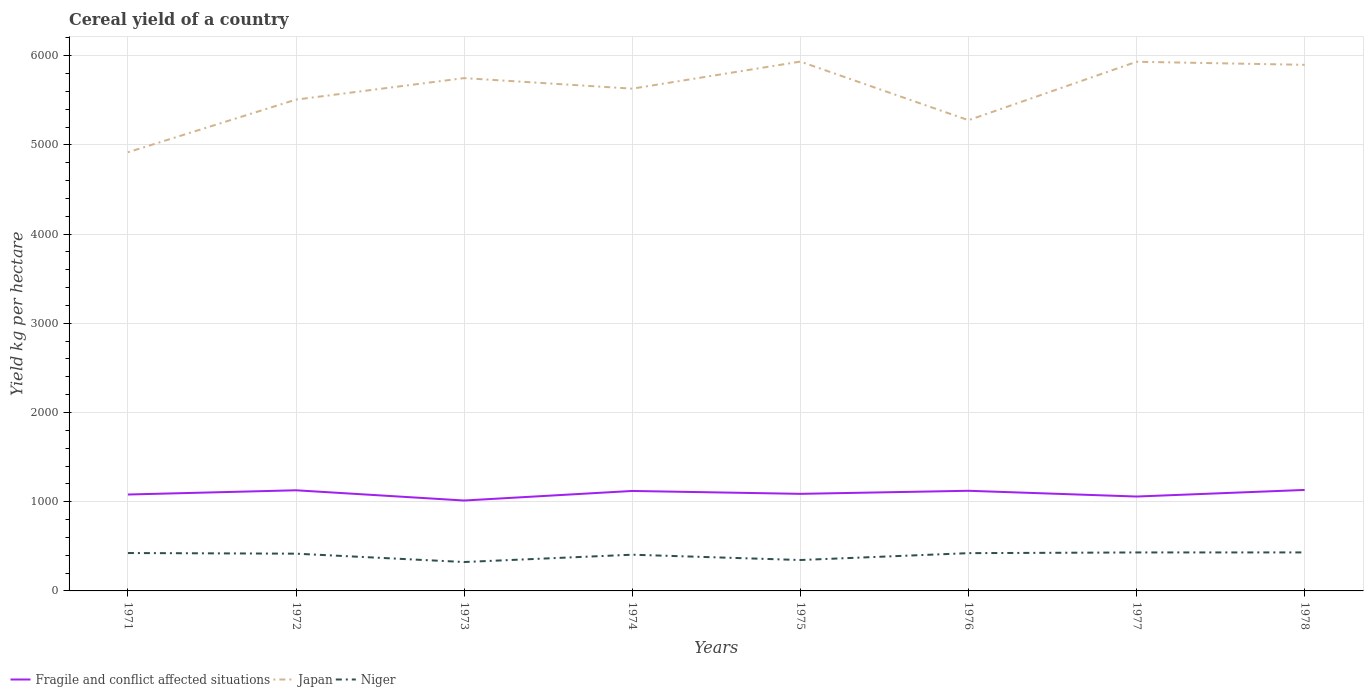Does the line corresponding to Japan intersect with the line corresponding to Fragile and conflict affected situations?
Offer a very short reply. No. Is the number of lines equal to the number of legend labels?
Make the answer very short. Yes. Across all years, what is the maximum total cereal yield in Japan?
Offer a terse response. 4917. What is the total total cereal yield in Fragile and conflict affected situations in the graph?
Your answer should be very brief. 5.6. What is the difference between the highest and the second highest total cereal yield in Niger?
Your answer should be compact. 107.6. What is the difference between the highest and the lowest total cereal yield in Japan?
Your response must be concise. 5. Is the total cereal yield in Niger strictly greater than the total cereal yield in Japan over the years?
Your answer should be very brief. Yes. How many lines are there?
Ensure brevity in your answer.  3. How many years are there in the graph?
Provide a succinct answer. 8. Does the graph contain grids?
Ensure brevity in your answer.  Yes. Where does the legend appear in the graph?
Provide a succinct answer. Bottom left. How many legend labels are there?
Offer a terse response. 3. How are the legend labels stacked?
Provide a succinct answer. Horizontal. What is the title of the graph?
Give a very brief answer. Cereal yield of a country. What is the label or title of the X-axis?
Provide a succinct answer. Years. What is the label or title of the Y-axis?
Your answer should be compact. Yield kg per hectare. What is the Yield kg per hectare of Fragile and conflict affected situations in 1971?
Give a very brief answer. 1080.58. What is the Yield kg per hectare in Japan in 1971?
Make the answer very short. 4917. What is the Yield kg per hectare in Niger in 1971?
Offer a very short reply. 424.77. What is the Yield kg per hectare in Fragile and conflict affected situations in 1972?
Provide a short and direct response. 1128.12. What is the Yield kg per hectare in Japan in 1972?
Offer a very short reply. 5507.19. What is the Yield kg per hectare in Niger in 1972?
Give a very brief answer. 417.58. What is the Yield kg per hectare in Fragile and conflict affected situations in 1973?
Your answer should be compact. 1013.39. What is the Yield kg per hectare in Japan in 1973?
Keep it short and to the point. 5748.08. What is the Yield kg per hectare in Niger in 1973?
Your response must be concise. 323.93. What is the Yield kg per hectare in Fragile and conflict affected situations in 1974?
Provide a short and direct response. 1120.53. What is the Yield kg per hectare in Japan in 1974?
Provide a succinct answer. 5629.96. What is the Yield kg per hectare in Niger in 1974?
Offer a very short reply. 405.96. What is the Yield kg per hectare of Fragile and conflict affected situations in 1975?
Offer a very short reply. 1088.23. What is the Yield kg per hectare of Japan in 1975?
Provide a succinct answer. 5933.27. What is the Yield kg per hectare of Niger in 1975?
Offer a terse response. 346.44. What is the Yield kg per hectare of Fragile and conflict affected situations in 1976?
Make the answer very short. 1122.52. What is the Yield kg per hectare of Japan in 1976?
Give a very brief answer. 5276.19. What is the Yield kg per hectare in Niger in 1976?
Ensure brevity in your answer.  423.41. What is the Yield kg per hectare of Fragile and conflict affected situations in 1977?
Make the answer very short. 1058.09. What is the Yield kg per hectare of Japan in 1977?
Provide a succinct answer. 5931.56. What is the Yield kg per hectare of Niger in 1977?
Your answer should be compact. 431.25. What is the Yield kg per hectare of Fragile and conflict affected situations in 1978?
Provide a succinct answer. 1131.86. What is the Yield kg per hectare of Japan in 1978?
Keep it short and to the point. 5897.02. What is the Yield kg per hectare of Niger in 1978?
Give a very brief answer. 431.54. Across all years, what is the maximum Yield kg per hectare in Fragile and conflict affected situations?
Make the answer very short. 1131.86. Across all years, what is the maximum Yield kg per hectare of Japan?
Your answer should be compact. 5933.27. Across all years, what is the maximum Yield kg per hectare of Niger?
Keep it short and to the point. 431.54. Across all years, what is the minimum Yield kg per hectare in Fragile and conflict affected situations?
Give a very brief answer. 1013.39. Across all years, what is the minimum Yield kg per hectare in Japan?
Provide a succinct answer. 4917. Across all years, what is the minimum Yield kg per hectare of Niger?
Provide a succinct answer. 323.93. What is the total Yield kg per hectare of Fragile and conflict affected situations in the graph?
Your response must be concise. 8743.31. What is the total Yield kg per hectare in Japan in the graph?
Make the answer very short. 4.48e+04. What is the total Yield kg per hectare of Niger in the graph?
Your response must be concise. 3204.89. What is the difference between the Yield kg per hectare in Fragile and conflict affected situations in 1971 and that in 1972?
Provide a succinct answer. -47.54. What is the difference between the Yield kg per hectare in Japan in 1971 and that in 1972?
Keep it short and to the point. -590.19. What is the difference between the Yield kg per hectare of Niger in 1971 and that in 1972?
Give a very brief answer. 7.19. What is the difference between the Yield kg per hectare of Fragile and conflict affected situations in 1971 and that in 1973?
Your answer should be compact. 67.2. What is the difference between the Yield kg per hectare of Japan in 1971 and that in 1973?
Your answer should be very brief. -831.09. What is the difference between the Yield kg per hectare in Niger in 1971 and that in 1973?
Offer a very short reply. 100.84. What is the difference between the Yield kg per hectare of Fragile and conflict affected situations in 1971 and that in 1974?
Offer a terse response. -39.95. What is the difference between the Yield kg per hectare in Japan in 1971 and that in 1974?
Give a very brief answer. -712.96. What is the difference between the Yield kg per hectare of Niger in 1971 and that in 1974?
Give a very brief answer. 18.81. What is the difference between the Yield kg per hectare in Fragile and conflict affected situations in 1971 and that in 1975?
Keep it short and to the point. -7.64. What is the difference between the Yield kg per hectare in Japan in 1971 and that in 1975?
Give a very brief answer. -1016.27. What is the difference between the Yield kg per hectare of Niger in 1971 and that in 1975?
Provide a succinct answer. 78.33. What is the difference between the Yield kg per hectare of Fragile and conflict affected situations in 1971 and that in 1976?
Offer a very short reply. -41.93. What is the difference between the Yield kg per hectare of Japan in 1971 and that in 1976?
Ensure brevity in your answer.  -359.19. What is the difference between the Yield kg per hectare in Niger in 1971 and that in 1976?
Provide a succinct answer. 1.36. What is the difference between the Yield kg per hectare of Fragile and conflict affected situations in 1971 and that in 1977?
Your answer should be very brief. 22.5. What is the difference between the Yield kg per hectare in Japan in 1971 and that in 1977?
Your answer should be compact. -1014.56. What is the difference between the Yield kg per hectare of Niger in 1971 and that in 1977?
Ensure brevity in your answer.  -6.48. What is the difference between the Yield kg per hectare in Fragile and conflict affected situations in 1971 and that in 1978?
Give a very brief answer. -51.28. What is the difference between the Yield kg per hectare of Japan in 1971 and that in 1978?
Make the answer very short. -980.03. What is the difference between the Yield kg per hectare of Niger in 1971 and that in 1978?
Your answer should be very brief. -6.76. What is the difference between the Yield kg per hectare of Fragile and conflict affected situations in 1972 and that in 1973?
Offer a terse response. 114.73. What is the difference between the Yield kg per hectare of Japan in 1972 and that in 1973?
Provide a short and direct response. -240.89. What is the difference between the Yield kg per hectare of Niger in 1972 and that in 1973?
Give a very brief answer. 93.65. What is the difference between the Yield kg per hectare of Fragile and conflict affected situations in 1972 and that in 1974?
Your answer should be very brief. 7.59. What is the difference between the Yield kg per hectare in Japan in 1972 and that in 1974?
Offer a terse response. -122.77. What is the difference between the Yield kg per hectare of Niger in 1972 and that in 1974?
Provide a short and direct response. 11.62. What is the difference between the Yield kg per hectare in Fragile and conflict affected situations in 1972 and that in 1975?
Offer a very short reply. 39.89. What is the difference between the Yield kg per hectare in Japan in 1972 and that in 1975?
Your response must be concise. -426.08. What is the difference between the Yield kg per hectare in Niger in 1972 and that in 1975?
Your answer should be very brief. 71.14. What is the difference between the Yield kg per hectare of Fragile and conflict affected situations in 1972 and that in 1976?
Keep it short and to the point. 5.6. What is the difference between the Yield kg per hectare of Japan in 1972 and that in 1976?
Provide a short and direct response. 231. What is the difference between the Yield kg per hectare in Niger in 1972 and that in 1976?
Ensure brevity in your answer.  -5.83. What is the difference between the Yield kg per hectare of Fragile and conflict affected situations in 1972 and that in 1977?
Give a very brief answer. 70.03. What is the difference between the Yield kg per hectare in Japan in 1972 and that in 1977?
Your response must be concise. -424.37. What is the difference between the Yield kg per hectare of Niger in 1972 and that in 1977?
Give a very brief answer. -13.67. What is the difference between the Yield kg per hectare of Fragile and conflict affected situations in 1972 and that in 1978?
Ensure brevity in your answer.  -3.74. What is the difference between the Yield kg per hectare in Japan in 1972 and that in 1978?
Make the answer very short. -389.83. What is the difference between the Yield kg per hectare in Niger in 1972 and that in 1978?
Offer a very short reply. -13.95. What is the difference between the Yield kg per hectare in Fragile and conflict affected situations in 1973 and that in 1974?
Keep it short and to the point. -107.15. What is the difference between the Yield kg per hectare in Japan in 1973 and that in 1974?
Give a very brief answer. 118.12. What is the difference between the Yield kg per hectare in Niger in 1973 and that in 1974?
Make the answer very short. -82.03. What is the difference between the Yield kg per hectare in Fragile and conflict affected situations in 1973 and that in 1975?
Offer a very short reply. -74.84. What is the difference between the Yield kg per hectare in Japan in 1973 and that in 1975?
Make the answer very short. -185.19. What is the difference between the Yield kg per hectare in Niger in 1973 and that in 1975?
Keep it short and to the point. -22.51. What is the difference between the Yield kg per hectare in Fragile and conflict affected situations in 1973 and that in 1976?
Your answer should be compact. -109.13. What is the difference between the Yield kg per hectare in Japan in 1973 and that in 1976?
Provide a short and direct response. 471.89. What is the difference between the Yield kg per hectare of Niger in 1973 and that in 1976?
Your answer should be very brief. -99.47. What is the difference between the Yield kg per hectare in Fragile and conflict affected situations in 1973 and that in 1977?
Your answer should be compact. -44.7. What is the difference between the Yield kg per hectare in Japan in 1973 and that in 1977?
Provide a succinct answer. -183.48. What is the difference between the Yield kg per hectare of Niger in 1973 and that in 1977?
Keep it short and to the point. -107.32. What is the difference between the Yield kg per hectare of Fragile and conflict affected situations in 1973 and that in 1978?
Offer a terse response. -118.47. What is the difference between the Yield kg per hectare of Japan in 1973 and that in 1978?
Provide a short and direct response. -148.94. What is the difference between the Yield kg per hectare in Niger in 1973 and that in 1978?
Offer a terse response. -107.6. What is the difference between the Yield kg per hectare of Fragile and conflict affected situations in 1974 and that in 1975?
Keep it short and to the point. 32.31. What is the difference between the Yield kg per hectare of Japan in 1974 and that in 1975?
Offer a terse response. -303.31. What is the difference between the Yield kg per hectare of Niger in 1974 and that in 1975?
Your answer should be compact. 59.52. What is the difference between the Yield kg per hectare in Fragile and conflict affected situations in 1974 and that in 1976?
Give a very brief answer. -1.98. What is the difference between the Yield kg per hectare in Japan in 1974 and that in 1976?
Your answer should be compact. 353.77. What is the difference between the Yield kg per hectare of Niger in 1974 and that in 1976?
Your answer should be very brief. -17.45. What is the difference between the Yield kg per hectare of Fragile and conflict affected situations in 1974 and that in 1977?
Offer a terse response. 62.45. What is the difference between the Yield kg per hectare of Japan in 1974 and that in 1977?
Provide a succinct answer. -301.6. What is the difference between the Yield kg per hectare of Niger in 1974 and that in 1977?
Keep it short and to the point. -25.29. What is the difference between the Yield kg per hectare of Fragile and conflict affected situations in 1974 and that in 1978?
Provide a succinct answer. -11.33. What is the difference between the Yield kg per hectare of Japan in 1974 and that in 1978?
Your answer should be very brief. -267.07. What is the difference between the Yield kg per hectare of Niger in 1974 and that in 1978?
Offer a terse response. -25.57. What is the difference between the Yield kg per hectare of Fragile and conflict affected situations in 1975 and that in 1976?
Provide a short and direct response. -34.29. What is the difference between the Yield kg per hectare in Japan in 1975 and that in 1976?
Provide a short and direct response. 657.08. What is the difference between the Yield kg per hectare in Niger in 1975 and that in 1976?
Your answer should be compact. -76.97. What is the difference between the Yield kg per hectare of Fragile and conflict affected situations in 1975 and that in 1977?
Make the answer very short. 30.14. What is the difference between the Yield kg per hectare of Japan in 1975 and that in 1977?
Make the answer very short. 1.71. What is the difference between the Yield kg per hectare of Niger in 1975 and that in 1977?
Your answer should be very brief. -84.81. What is the difference between the Yield kg per hectare in Fragile and conflict affected situations in 1975 and that in 1978?
Your answer should be very brief. -43.64. What is the difference between the Yield kg per hectare in Japan in 1975 and that in 1978?
Your answer should be very brief. 36.24. What is the difference between the Yield kg per hectare in Niger in 1975 and that in 1978?
Offer a terse response. -85.09. What is the difference between the Yield kg per hectare of Fragile and conflict affected situations in 1976 and that in 1977?
Your answer should be very brief. 64.43. What is the difference between the Yield kg per hectare in Japan in 1976 and that in 1977?
Offer a terse response. -655.37. What is the difference between the Yield kg per hectare in Niger in 1976 and that in 1977?
Your response must be concise. -7.84. What is the difference between the Yield kg per hectare of Fragile and conflict affected situations in 1976 and that in 1978?
Keep it short and to the point. -9.35. What is the difference between the Yield kg per hectare of Japan in 1976 and that in 1978?
Your response must be concise. -620.84. What is the difference between the Yield kg per hectare of Niger in 1976 and that in 1978?
Ensure brevity in your answer.  -8.13. What is the difference between the Yield kg per hectare in Fragile and conflict affected situations in 1977 and that in 1978?
Provide a succinct answer. -73.77. What is the difference between the Yield kg per hectare in Japan in 1977 and that in 1978?
Offer a very short reply. 34.53. What is the difference between the Yield kg per hectare in Niger in 1977 and that in 1978?
Make the answer very short. -0.28. What is the difference between the Yield kg per hectare of Fragile and conflict affected situations in 1971 and the Yield kg per hectare of Japan in 1972?
Your response must be concise. -4426.61. What is the difference between the Yield kg per hectare of Fragile and conflict affected situations in 1971 and the Yield kg per hectare of Niger in 1972?
Provide a succinct answer. 663. What is the difference between the Yield kg per hectare in Japan in 1971 and the Yield kg per hectare in Niger in 1972?
Provide a succinct answer. 4499.41. What is the difference between the Yield kg per hectare in Fragile and conflict affected situations in 1971 and the Yield kg per hectare in Japan in 1973?
Provide a succinct answer. -4667.5. What is the difference between the Yield kg per hectare of Fragile and conflict affected situations in 1971 and the Yield kg per hectare of Niger in 1973?
Provide a short and direct response. 756.65. What is the difference between the Yield kg per hectare of Japan in 1971 and the Yield kg per hectare of Niger in 1973?
Provide a succinct answer. 4593.06. What is the difference between the Yield kg per hectare of Fragile and conflict affected situations in 1971 and the Yield kg per hectare of Japan in 1974?
Ensure brevity in your answer.  -4549.37. What is the difference between the Yield kg per hectare in Fragile and conflict affected situations in 1971 and the Yield kg per hectare in Niger in 1974?
Your answer should be very brief. 674.62. What is the difference between the Yield kg per hectare in Japan in 1971 and the Yield kg per hectare in Niger in 1974?
Your response must be concise. 4511.03. What is the difference between the Yield kg per hectare of Fragile and conflict affected situations in 1971 and the Yield kg per hectare of Japan in 1975?
Keep it short and to the point. -4852.68. What is the difference between the Yield kg per hectare in Fragile and conflict affected situations in 1971 and the Yield kg per hectare in Niger in 1975?
Offer a terse response. 734.14. What is the difference between the Yield kg per hectare in Japan in 1971 and the Yield kg per hectare in Niger in 1975?
Make the answer very short. 4570.55. What is the difference between the Yield kg per hectare of Fragile and conflict affected situations in 1971 and the Yield kg per hectare of Japan in 1976?
Your answer should be compact. -4195.6. What is the difference between the Yield kg per hectare of Fragile and conflict affected situations in 1971 and the Yield kg per hectare of Niger in 1976?
Provide a succinct answer. 657.17. What is the difference between the Yield kg per hectare of Japan in 1971 and the Yield kg per hectare of Niger in 1976?
Keep it short and to the point. 4493.59. What is the difference between the Yield kg per hectare in Fragile and conflict affected situations in 1971 and the Yield kg per hectare in Japan in 1977?
Your response must be concise. -4850.97. What is the difference between the Yield kg per hectare of Fragile and conflict affected situations in 1971 and the Yield kg per hectare of Niger in 1977?
Offer a terse response. 649.33. What is the difference between the Yield kg per hectare in Japan in 1971 and the Yield kg per hectare in Niger in 1977?
Provide a succinct answer. 4485.74. What is the difference between the Yield kg per hectare in Fragile and conflict affected situations in 1971 and the Yield kg per hectare in Japan in 1978?
Keep it short and to the point. -4816.44. What is the difference between the Yield kg per hectare of Fragile and conflict affected situations in 1971 and the Yield kg per hectare of Niger in 1978?
Provide a succinct answer. 649.05. What is the difference between the Yield kg per hectare of Japan in 1971 and the Yield kg per hectare of Niger in 1978?
Provide a short and direct response. 4485.46. What is the difference between the Yield kg per hectare in Fragile and conflict affected situations in 1972 and the Yield kg per hectare in Japan in 1973?
Offer a very short reply. -4619.96. What is the difference between the Yield kg per hectare in Fragile and conflict affected situations in 1972 and the Yield kg per hectare in Niger in 1973?
Provide a short and direct response. 804.18. What is the difference between the Yield kg per hectare of Japan in 1972 and the Yield kg per hectare of Niger in 1973?
Your response must be concise. 5183.26. What is the difference between the Yield kg per hectare in Fragile and conflict affected situations in 1972 and the Yield kg per hectare in Japan in 1974?
Your answer should be compact. -4501.84. What is the difference between the Yield kg per hectare in Fragile and conflict affected situations in 1972 and the Yield kg per hectare in Niger in 1974?
Your answer should be compact. 722.16. What is the difference between the Yield kg per hectare in Japan in 1972 and the Yield kg per hectare in Niger in 1974?
Ensure brevity in your answer.  5101.23. What is the difference between the Yield kg per hectare of Fragile and conflict affected situations in 1972 and the Yield kg per hectare of Japan in 1975?
Your response must be concise. -4805.15. What is the difference between the Yield kg per hectare in Fragile and conflict affected situations in 1972 and the Yield kg per hectare in Niger in 1975?
Provide a short and direct response. 781.68. What is the difference between the Yield kg per hectare in Japan in 1972 and the Yield kg per hectare in Niger in 1975?
Offer a very short reply. 5160.75. What is the difference between the Yield kg per hectare of Fragile and conflict affected situations in 1972 and the Yield kg per hectare of Japan in 1976?
Offer a terse response. -4148.07. What is the difference between the Yield kg per hectare in Fragile and conflict affected situations in 1972 and the Yield kg per hectare in Niger in 1976?
Give a very brief answer. 704.71. What is the difference between the Yield kg per hectare in Japan in 1972 and the Yield kg per hectare in Niger in 1976?
Your answer should be compact. 5083.78. What is the difference between the Yield kg per hectare of Fragile and conflict affected situations in 1972 and the Yield kg per hectare of Japan in 1977?
Your answer should be very brief. -4803.44. What is the difference between the Yield kg per hectare in Fragile and conflict affected situations in 1972 and the Yield kg per hectare in Niger in 1977?
Provide a short and direct response. 696.87. What is the difference between the Yield kg per hectare in Japan in 1972 and the Yield kg per hectare in Niger in 1977?
Your response must be concise. 5075.94. What is the difference between the Yield kg per hectare of Fragile and conflict affected situations in 1972 and the Yield kg per hectare of Japan in 1978?
Your answer should be very brief. -4768.9. What is the difference between the Yield kg per hectare in Fragile and conflict affected situations in 1972 and the Yield kg per hectare in Niger in 1978?
Keep it short and to the point. 696.58. What is the difference between the Yield kg per hectare in Japan in 1972 and the Yield kg per hectare in Niger in 1978?
Your answer should be compact. 5075.65. What is the difference between the Yield kg per hectare of Fragile and conflict affected situations in 1973 and the Yield kg per hectare of Japan in 1974?
Your response must be concise. -4616.57. What is the difference between the Yield kg per hectare in Fragile and conflict affected situations in 1973 and the Yield kg per hectare in Niger in 1974?
Make the answer very short. 607.43. What is the difference between the Yield kg per hectare in Japan in 1973 and the Yield kg per hectare in Niger in 1974?
Your answer should be compact. 5342.12. What is the difference between the Yield kg per hectare in Fragile and conflict affected situations in 1973 and the Yield kg per hectare in Japan in 1975?
Provide a succinct answer. -4919.88. What is the difference between the Yield kg per hectare in Fragile and conflict affected situations in 1973 and the Yield kg per hectare in Niger in 1975?
Your answer should be very brief. 666.95. What is the difference between the Yield kg per hectare of Japan in 1973 and the Yield kg per hectare of Niger in 1975?
Make the answer very short. 5401.64. What is the difference between the Yield kg per hectare of Fragile and conflict affected situations in 1973 and the Yield kg per hectare of Japan in 1976?
Keep it short and to the point. -4262.8. What is the difference between the Yield kg per hectare in Fragile and conflict affected situations in 1973 and the Yield kg per hectare in Niger in 1976?
Your answer should be compact. 589.98. What is the difference between the Yield kg per hectare in Japan in 1973 and the Yield kg per hectare in Niger in 1976?
Provide a short and direct response. 5324.67. What is the difference between the Yield kg per hectare in Fragile and conflict affected situations in 1973 and the Yield kg per hectare in Japan in 1977?
Provide a succinct answer. -4918.17. What is the difference between the Yield kg per hectare in Fragile and conflict affected situations in 1973 and the Yield kg per hectare in Niger in 1977?
Make the answer very short. 582.13. What is the difference between the Yield kg per hectare of Japan in 1973 and the Yield kg per hectare of Niger in 1977?
Offer a terse response. 5316.83. What is the difference between the Yield kg per hectare in Fragile and conflict affected situations in 1973 and the Yield kg per hectare in Japan in 1978?
Offer a very short reply. -4883.64. What is the difference between the Yield kg per hectare of Fragile and conflict affected situations in 1973 and the Yield kg per hectare of Niger in 1978?
Offer a very short reply. 581.85. What is the difference between the Yield kg per hectare in Japan in 1973 and the Yield kg per hectare in Niger in 1978?
Give a very brief answer. 5316.55. What is the difference between the Yield kg per hectare of Fragile and conflict affected situations in 1974 and the Yield kg per hectare of Japan in 1975?
Give a very brief answer. -4812.73. What is the difference between the Yield kg per hectare in Fragile and conflict affected situations in 1974 and the Yield kg per hectare in Niger in 1975?
Give a very brief answer. 774.09. What is the difference between the Yield kg per hectare in Japan in 1974 and the Yield kg per hectare in Niger in 1975?
Keep it short and to the point. 5283.51. What is the difference between the Yield kg per hectare of Fragile and conflict affected situations in 1974 and the Yield kg per hectare of Japan in 1976?
Your response must be concise. -4155.65. What is the difference between the Yield kg per hectare of Fragile and conflict affected situations in 1974 and the Yield kg per hectare of Niger in 1976?
Give a very brief answer. 697.12. What is the difference between the Yield kg per hectare in Japan in 1974 and the Yield kg per hectare in Niger in 1976?
Give a very brief answer. 5206.55. What is the difference between the Yield kg per hectare of Fragile and conflict affected situations in 1974 and the Yield kg per hectare of Japan in 1977?
Provide a succinct answer. -4811.02. What is the difference between the Yield kg per hectare of Fragile and conflict affected situations in 1974 and the Yield kg per hectare of Niger in 1977?
Ensure brevity in your answer.  689.28. What is the difference between the Yield kg per hectare in Japan in 1974 and the Yield kg per hectare in Niger in 1977?
Your answer should be very brief. 5198.7. What is the difference between the Yield kg per hectare in Fragile and conflict affected situations in 1974 and the Yield kg per hectare in Japan in 1978?
Offer a very short reply. -4776.49. What is the difference between the Yield kg per hectare in Fragile and conflict affected situations in 1974 and the Yield kg per hectare in Niger in 1978?
Provide a short and direct response. 689. What is the difference between the Yield kg per hectare of Japan in 1974 and the Yield kg per hectare of Niger in 1978?
Your response must be concise. 5198.42. What is the difference between the Yield kg per hectare of Fragile and conflict affected situations in 1975 and the Yield kg per hectare of Japan in 1976?
Offer a very short reply. -4187.96. What is the difference between the Yield kg per hectare of Fragile and conflict affected situations in 1975 and the Yield kg per hectare of Niger in 1976?
Ensure brevity in your answer.  664.82. What is the difference between the Yield kg per hectare of Japan in 1975 and the Yield kg per hectare of Niger in 1976?
Keep it short and to the point. 5509.86. What is the difference between the Yield kg per hectare in Fragile and conflict affected situations in 1975 and the Yield kg per hectare in Japan in 1977?
Make the answer very short. -4843.33. What is the difference between the Yield kg per hectare of Fragile and conflict affected situations in 1975 and the Yield kg per hectare of Niger in 1977?
Your answer should be compact. 656.97. What is the difference between the Yield kg per hectare of Japan in 1975 and the Yield kg per hectare of Niger in 1977?
Make the answer very short. 5502.01. What is the difference between the Yield kg per hectare in Fragile and conflict affected situations in 1975 and the Yield kg per hectare in Japan in 1978?
Provide a short and direct response. -4808.8. What is the difference between the Yield kg per hectare of Fragile and conflict affected situations in 1975 and the Yield kg per hectare of Niger in 1978?
Provide a short and direct response. 656.69. What is the difference between the Yield kg per hectare in Japan in 1975 and the Yield kg per hectare in Niger in 1978?
Provide a short and direct response. 5501.73. What is the difference between the Yield kg per hectare of Fragile and conflict affected situations in 1976 and the Yield kg per hectare of Japan in 1977?
Provide a succinct answer. -4809.04. What is the difference between the Yield kg per hectare in Fragile and conflict affected situations in 1976 and the Yield kg per hectare in Niger in 1977?
Provide a short and direct response. 691.26. What is the difference between the Yield kg per hectare of Japan in 1976 and the Yield kg per hectare of Niger in 1977?
Keep it short and to the point. 4844.93. What is the difference between the Yield kg per hectare of Fragile and conflict affected situations in 1976 and the Yield kg per hectare of Japan in 1978?
Offer a terse response. -4774.51. What is the difference between the Yield kg per hectare in Fragile and conflict affected situations in 1976 and the Yield kg per hectare in Niger in 1978?
Your response must be concise. 690.98. What is the difference between the Yield kg per hectare in Japan in 1976 and the Yield kg per hectare in Niger in 1978?
Make the answer very short. 4844.65. What is the difference between the Yield kg per hectare in Fragile and conflict affected situations in 1977 and the Yield kg per hectare in Japan in 1978?
Your response must be concise. -4838.93. What is the difference between the Yield kg per hectare of Fragile and conflict affected situations in 1977 and the Yield kg per hectare of Niger in 1978?
Provide a succinct answer. 626.55. What is the difference between the Yield kg per hectare in Japan in 1977 and the Yield kg per hectare in Niger in 1978?
Make the answer very short. 5500.02. What is the average Yield kg per hectare in Fragile and conflict affected situations per year?
Your response must be concise. 1092.91. What is the average Yield kg per hectare in Japan per year?
Provide a succinct answer. 5605.03. What is the average Yield kg per hectare in Niger per year?
Offer a very short reply. 400.61. In the year 1971, what is the difference between the Yield kg per hectare of Fragile and conflict affected situations and Yield kg per hectare of Japan?
Offer a very short reply. -3836.41. In the year 1971, what is the difference between the Yield kg per hectare of Fragile and conflict affected situations and Yield kg per hectare of Niger?
Offer a very short reply. 655.81. In the year 1971, what is the difference between the Yield kg per hectare in Japan and Yield kg per hectare in Niger?
Make the answer very short. 4492.22. In the year 1972, what is the difference between the Yield kg per hectare in Fragile and conflict affected situations and Yield kg per hectare in Japan?
Your answer should be very brief. -4379.07. In the year 1972, what is the difference between the Yield kg per hectare of Fragile and conflict affected situations and Yield kg per hectare of Niger?
Provide a short and direct response. 710.54. In the year 1972, what is the difference between the Yield kg per hectare in Japan and Yield kg per hectare in Niger?
Offer a terse response. 5089.61. In the year 1973, what is the difference between the Yield kg per hectare of Fragile and conflict affected situations and Yield kg per hectare of Japan?
Give a very brief answer. -4734.69. In the year 1973, what is the difference between the Yield kg per hectare of Fragile and conflict affected situations and Yield kg per hectare of Niger?
Give a very brief answer. 689.45. In the year 1973, what is the difference between the Yield kg per hectare of Japan and Yield kg per hectare of Niger?
Your answer should be very brief. 5424.15. In the year 1974, what is the difference between the Yield kg per hectare in Fragile and conflict affected situations and Yield kg per hectare in Japan?
Make the answer very short. -4509.42. In the year 1974, what is the difference between the Yield kg per hectare of Fragile and conflict affected situations and Yield kg per hectare of Niger?
Provide a short and direct response. 714.57. In the year 1974, what is the difference between the Yield kg per hectare of Japan and Yield kg per hectare of Niger?
Offer a terse response. 5224. In the year 1975, what is the difference between the Yield kg per hectare in Fragile and conflict affected situations and Yield kg per hectare in Japan?
Your answer should be very brief. -4845.04. In the year 1975, what is the difference between the Yield kg per hectare in Fragile and conflict affected situations and Yield kg per hectare in Niger?
Make the answer very short. 741.78. In the year 1975, what is the difference between the Yield kg per hectare of Japan and Yield kg per hectare of Niger?
Ensure brevity in your answer.  5586.82. In the year 1976, what is the difference between the Yield kg per hectare of Fragile and conflict affected situations and Yield kg per hectare of Japan?
Ensure brevity in your answer.  -4153.67. In the year 1976, what is the difference between the Yield kg per hectare of Fragile and conflict affected situations and Yield kg per hectare of Niger?
Provide a succinct answer. 699.11. In the year 1976, what is the difference between the Yield kg per hectare of Japan and Yield kg per hectare of Niger?
Your answer should be very brief. 4852.78. In the year 1977, what is the difference between the Yield kg per hectare in Fragile and conflict affected situations and Yield kg per hectare in Japan?
Your response must be concise. -4873.47. In the year 1977, what is the difference between the Yield kg per hectare of Fragile and conflict affected situations and Yield kg per hectare of Niger?
Provide a short and direct response. 626.84. In the year 1977, what is the difference between the Yield kg per hectare of Japan and Yield kg per hectare of Niger?
Provide a succinct answer. 5500.31. In the year 1978, what is the difference between the Yield kg per hectare of Fragile and conflict affected situations and Yield kg per hectare of Japan?
Give a very brief answer. -4765.16. In the year 1978, what is the difference between the Yield kg per hectare in Fragile and conflict affected situations and Yield kg per hectare in Niger?
Make the answer very short. 700.33. In the year 1978, what is the difference between the Yield kg per hectare of Japan and Yield kg per hectare of Niger?
Ensure brevity in your answer.  5465.49. What is the ratio of the Yield kg per hectare in Fragile and conflict affected situations in 1971 to that in 1972?
Offer a terse response. 0.96. What is the ratio of the Yield kg per hectare of Japan in 1971 to that in 1972?
Your response must be concise. 0.89. What is the ratio of the Yield kg per hectare of Niger in 1971 to that in 1972?
Offer a very short reply. 1.02. What is the ratio of the Yield kg per hectare in Fragile and conflict affected situations in 1971 to that in 1973?
Keep it short and to the point. 1.07. What is the ratio of the Yield kg per hectare in Japan in 1971 to that in 1973?
Make the answer very short. 0.86. What is the ratio of the Yield kg per hectare of Niger in 1971 to that in 1973?
Make the answer very short. 1.31. What is the ratio of the Yield kg per hectare of Fragile and conflict affected situations in 1971 to that in 1974?
Your answer should be very brief. 0.96. What is the ratio of the Yield kg per hectare in Japan in 1971 to that in 1974?
Ensure brevity in your answer.  0.87. What is the ratio of the Yield kg per hectare in Niger in 1971 to that in 1974?
Give a very brief answer. 1.05. What is the ratio of the Yield kg per hectare of Japan in 1971 to that in 1975?
Your answer should be compact. 0.83. What is the ratio of the Yield kg per hectare of Niger in 1971 to that in 1975?
Provide a succinct answer. 1.23. What is the ratio of the Yield kg per hectare in Fragile and conflict affected situations in 1971 to that in 1976?
Your answer should be compact. 0.96. What is the ratio of the Yield kg per hectare of Japan in 1971 to that in 1976?
Your response must be concise. 0.93. What is the ratio of the Yield kg per hectare in Niger in 1971 to that in 1976?
Offer a terse response. 1. What is the ratio of the Yield kg per hectare in Fragile and conflict affected situations in 1971 to that in 1977?
Your answer should be very brief. 1.02. What is the ratio of the Yield kg per hectare in Japan in 1971 to that in 1977?
Make the answer very short. 0.83. What is the ratio of the Yield kg per hectare in Fragile and conflict affected situations in 1971 to that in 1978?
Ensure brevity in your answer.  0.95. What is the ratio of the Yield kg per hectare of Japan in 1971 to that in 1978?
Your answer should be compact. 0.83. What is the ratio of the Yield kg per hectare of Niger in 1971 to that in 1978?
Your answer should be compact. 0.98. What is the ratio of the Yield kg per hectare of Fragile and conflict affected situations in 1972 to that in 1973?
Offer a very short reply. 1.11. What is the ratio of the Yield kg per hectare of Japan in 1972 to that in 1973?
Provide a short and direct response. 0.96. What is the ratio of the Yield kg per hectare of Niger in 1972 to that in 1973?
Offer a terse response. 1.29. What is the ratio of the Yield kg per hectare of Fragile and conflict affected situations in 1972 to that in 1974?
Ensure brevity in your answer.  1.01. What is the ratio of the Yield kg per hectare of Japan in 1972 to that in 1974?
Provide a short and direct response. 0.98. What is the ratio of the Yield kg per hectare of Niger in 1972 to that in 1974?
Offer a terse response. 1.03. What is the ratio of the Yield kg per hectare of Fragile and conflict affected situations in 1972 to that in 1975?
Keep it short and to the point. 1.04. What is the ratio of the Yield kg per hectare in Japan in 1972 to that in 1975?
Offer a terse response. 0.93. What is the ratio of the Yield kg per hectare in Niger in 1972 to that in 1975?
Keep it short and to the point. 1.21. What is the ratio of the Yield kg per hectare in Japan in 1972 to that in 1976?
Provide a succinct answer. 1.04. What is the ratio of the Yield kg per hectare of Niger in 1972 to that in 1976?
Ensure brevity in your answer.  0.99. What is the ratio of the Yield kg per hectare of Fragile and conflict affected situations in 1972 to that in 1977?
Your response must be concise. 1.07. What is the ratio of the Yield kg per hectare of Japan in 1972 to that in 1977?
Give a very brief answer. 0.93. What is the ratio of the Yield kg per hectare of Niger in 1972 to that in 1977?
Your answer should be compact. 0.97. What is the ratio of the Yield kg per hectare of Japan in 1972 to that in 1978?
Ensure brevity in your answer.  0.93. What is the ratio of the Yield kg per hectare in Fragile and conflict affected situations in 1973 to that in 1974?
Give a very brief answer. 0.9. What is the ratio of the Yield kg per hectare in Japan in 1973 to that in 1974?
Ensure brevity in your answer.  1.02. What is the ratio of the Yield kg per hectare in Niger in 1973 to that in 1974?
Your answer should be very brief. 0.8. What is the ratio of the Yield kg per hectare of Fragile and conflict affected situations in 1973 to that in 1975?
Make the answer very short. 0.93. What is the ratio of the Yield kg per hectare in Japan in 1973 to that in 1975?
Give a very brief answer. 0.97. What is the ratio of the Yield kg per hectare in Niger in 1973 to that in 1975?
Your answer should be very brief. 0.94. What is the ratio of the Yield kg per hectare of Fragile and conflict affected situations in 1973 to that in 1976?
Your answer should be compact. 0.9. What is the ratio of the Yield kg per hectare in Japan in 1973 to that in 1976?
Offer a very short reply. 1.09. What is the ratio of the Yield kg per hectare in Niger in 1973 to that in 1976?
Give a very brief answer. 0.77. What is the ratio of the Yield kg per hectare of Fragile and conflict affected situations in 1973 to that in 1977?
Provide a succinct answer. 0.96. What is the ratio of the Yield kg per hectare of Japan in 1973 to that in 1977?
Provide a succinct answer. 0.97. What is the ratio of the Yield kg per hectare in Niger in 1973 to that in 1977?
Provide a short and direct response. 0.75. What is the ratio of the Yield kg per hectare of Fragile and conflict affected situations in 1973 to that in 1978?
Provide a short and direct response. 0.9. What is the ratio of the Yield kg per hectare in Japan in 1973 to that in 1978?
Offer a terse response. 0.97. What is the ratio of the Yield kg per hectare in Niger in 1973 to that in 1978?
Provide a short and direct response. 0.75. What is the ratio of the Yield kg per hectare of Fragile and conflict affected situations in 1974 to that in 1975?
Your response must be concise. 1.03. What is the ratio of the Yield kg per hectare in Japan in 1974 to that in 1975?
Provide a succinct answer. 0.95. What is the ratio of the Yield kg per hectare of Niger in 1974 to that in 1975?
Offer a terse response. 1.17. What is the ratio of the Yield kg per hectare of Japan in 1974 to that in 1976?
Offer a very short reply. 1.07. What is the ratio of the Yield kg per hectare of Niger in 1974 to that in 1976?
Ensure brevity in your answer.  0.96. What is the ratio of the Yield kg per hectare in Fragile and conflict affected situations in 1974 to that in 1977?
Provide a succinct answer. 1.06. What is the ratio of the Yield kg per hectare of Japan in 1974 to that in 1977?
Your response must be concise. 0.95. What is the ratio of the Yield kg per hectare in Niger in 1974 to that in 1977?
Give a very brief answer. 0.94. What is the ratio of the Yield kg per hectare in Fragile and conflict affected situations in 1974 to that in 1978?
Ensure brevity in your answer.  0.99. What is the ratio of the Yield kg per hectare of Japan in 1974 to that in 1978?
Your response must be concise. 0.95. What is the ratio of the Yield kg per hectare in Niger in 1974 to that in 1978?
Your answer should be compact. 0.94. What is the ratio of the Yield kg per hectare of Fragile and conflict affected situations in 1975 to that in 1976?
Your answer should be very brief. 0.97. What is the ratio of the Yield kg per hectare in Japan in 1975 to that in 1976?
Keep it short and to the point. 1.12. What is the ratio of the Yield kg per hectare in Niger in 1975 to that in 1976?
Your answer should be very brief. 0.82. What is the ratio of the Yield kg per hectare in Fragile and conflict affected situations in 1975 to that in 1977?
Keep it short and to the point. 1.03. What is the ratio of the Yield kg per hectare in Japan in 1975 to that in 1977?
Provide a succinct answer. 1. What is the ratio of the Yield kg per hectare in Niger in 1975 to that in 1977?
Provide a short and direct response. 0.8. What is the ratio of the Yield kg per hectare in Fragile and conflict affected situations in 1975 to that in 1978?
Offer a very short reply. 0.96. What is the ratio of the Yield kg per hectare in Japan in 1975 to that in 1978?
Offer a very short reply. 1.01. What is the ratio of the Yield kg per hectare of Niger in 1975 to that in 1978?
Offer a terse response. 0.8. What is the ratio of the Yield kg per hectare of Fragile and conflict affected situations in 1976 to that in 1977?
Your answer should be very brief. 1.06. What is the ratio of the Yield kg per hectare in Japan in 1976 to that in 1977?
Give a very brief answer. 0.89. What is the ratio of the Yield kg per hectare in Niger in 1976 to that in 1977?
Your response must be concise. 0.98. What is the ratio of the Yield kg per hectare in Fragile and conflict affected situations in 1976 to that in 1978?
Offer a very short reply. 0.99. What is the ratio of the Yield kg per hectare of Japan in 1976 to that in 1978?
Offer a terse response. 0.89. What is the ratio of the Yield kg per hectare of Niger in 1976 to that in 1978?
Your answer should be very brief. 0.98. What is the ratio of the Yield kg per hectare of Fragile and conflict affected situations in 1977 to that in 1978?
Provide a succinct answer. 0.93. What is the ratio of the Yield kg per hectare in Japan in 1977 to that in 1978?
Your answer should be very brief. 1.01. What is the difference between the highest and the second highest Yield kg per hectare of Fragile and conflict affected situations?
Your answer should be compact. 3.74. What is the difference between the highest and the second highest Yield kg per hectare of Japan?
Your response must be concise. 1.71. What is the difference between the highest and the second highest Yield kg per hectare of Niger?
Give a very brief answer. 0.28. What is the difference between the highest and the lowest Yield kg per hectare in Fragile and conflict affected situations?
Provide a succinct answer. 118.47. What is the difference between the highest and the lowest Yield kg per hectare in Japan?
Offer a terse response. 1016.27. What is the difference between the highest and the lowest Yield kg per hectare in Niger?
Ensure brevity in your answer.  107.6. 